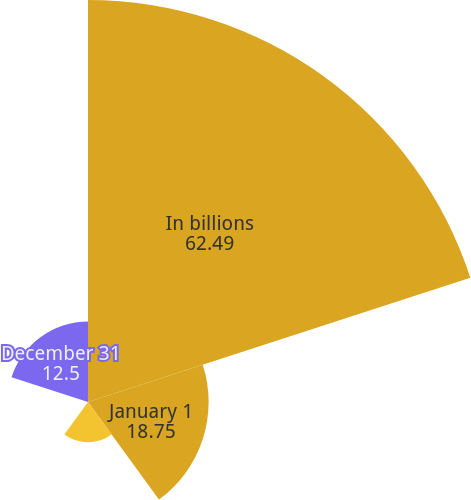Convert chart to OTSL. <chart><loc_0><loc_0><loc_500><loc_500><pie_chart><fcel>In billions<fcel>January 1<fcel>Maturities<fcel>Other<fcel>December 31<nl><fcel>62.49%<fcel>18.75%<fcel>6.25%<fcel>0.0%<fcel>12.5%<nl></chart> 